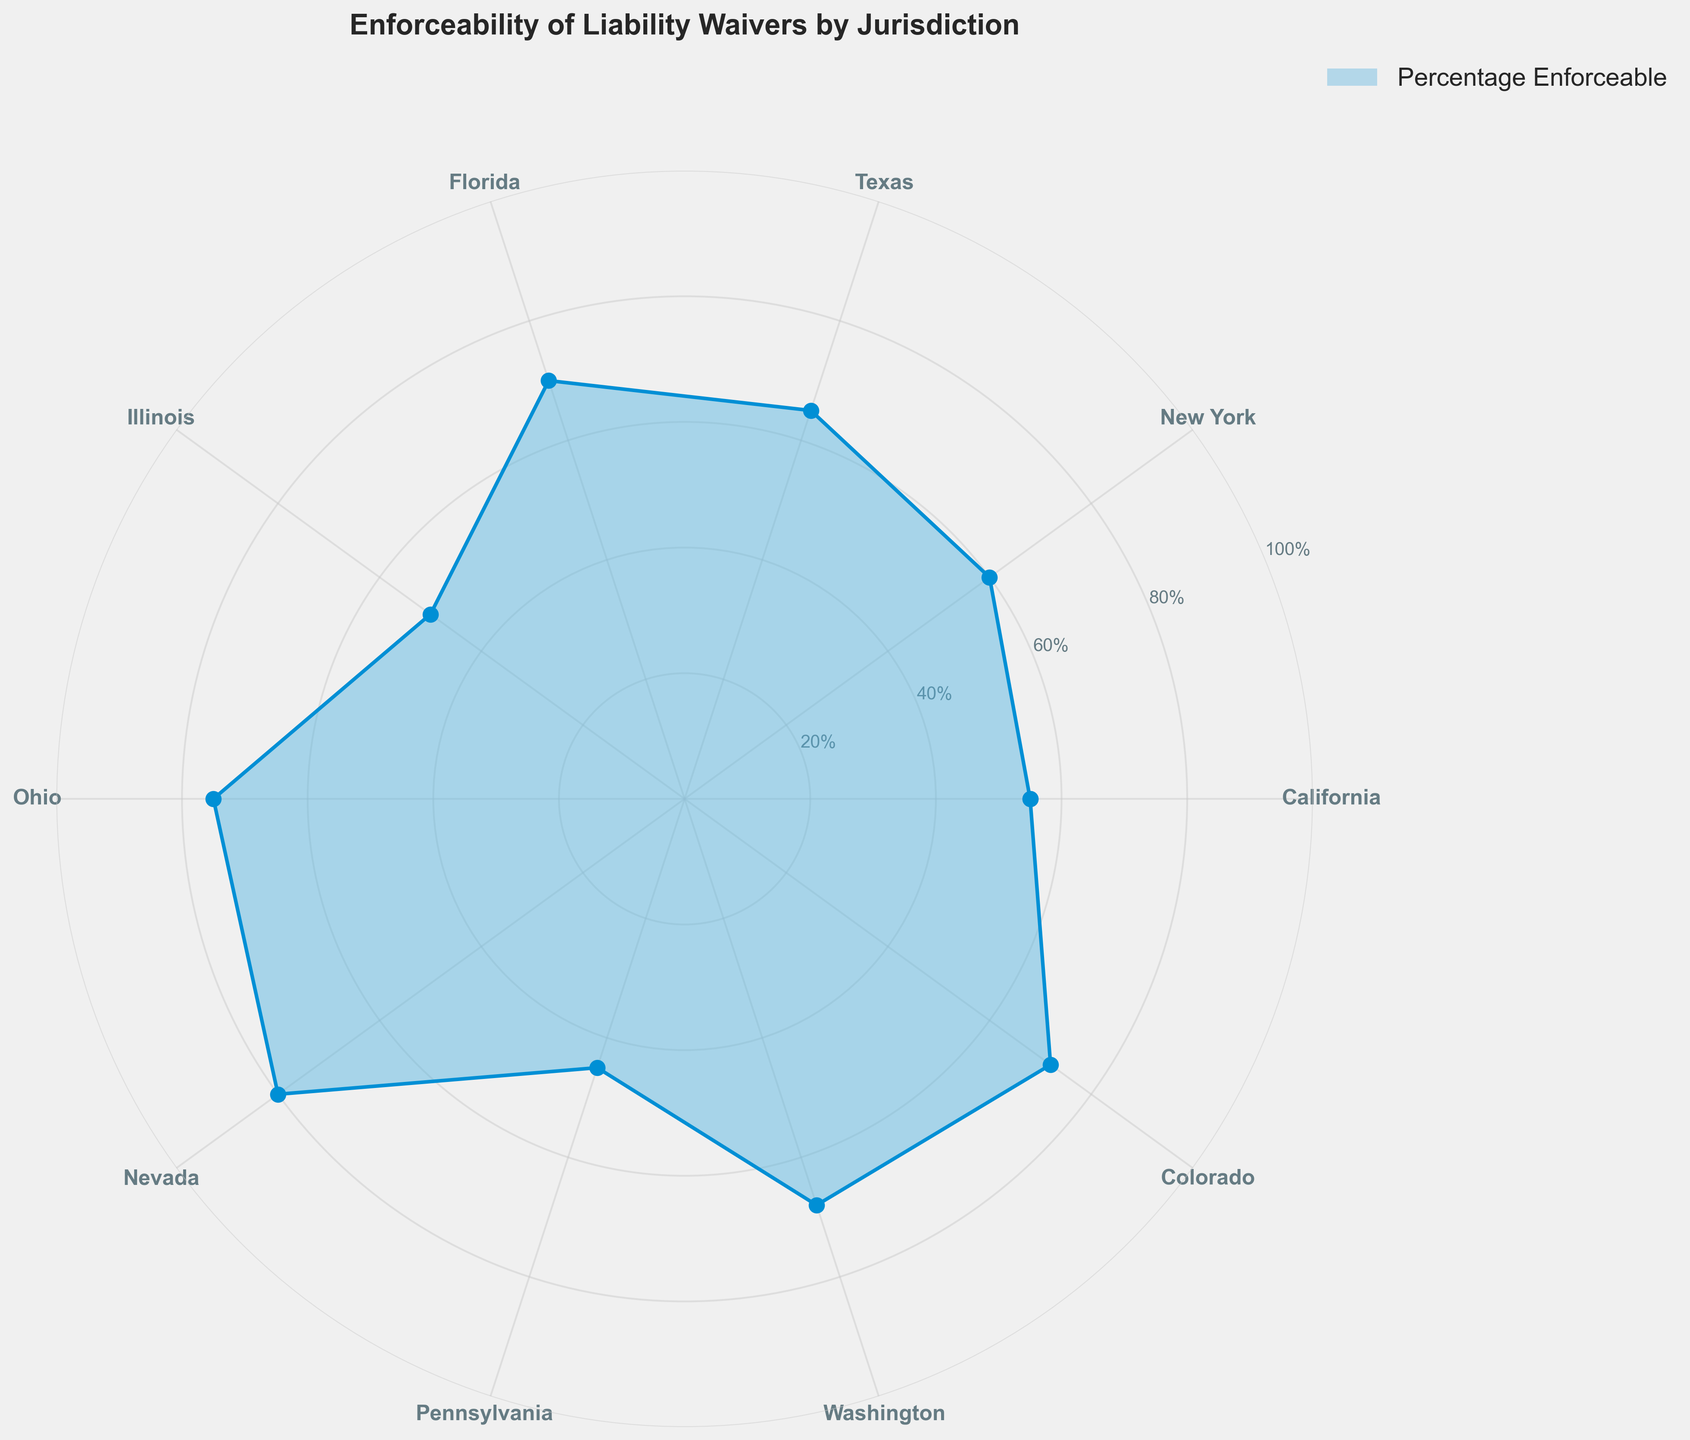what is the highest percentage of enforceable liability waivers among the jurisdictions? The figure shows the percentage enforceable for each jurisdiction on a polar area chart. By looking at the highest point on the chart, we see that Nevada has the highest percentage at 80%
Answer: 80% Which jurisdiction has the lowest enforceable rate for liability waivers? By observing the polar area chart, the shortest bar corresponds to Pennsylvania, indicating it has the lowest enforceable rate at 45%
Answer: Pennsylvania How many jurisdictions have an enforceability percentage higher than 65%? From the chart, we identify jurisdictions with percentages greater than 65%. They are Texas (65%), Florida (70%), Ohio (75%), Nevada (80%), Washington (68%), and Colorado (72%). Therefore, there are 6 jurisdictions.
Answer: 6 What is the average enforceability percentage across all jurisdictions? To find the average, sum up the enforceability percentages of all jurisdictions and divide by the number of jurisdictions: (55 + 60 + 65 + 70 + 50 + 75 + 80 + 45 + 68 + 72) / 10 = 64%
Answer: 64% Which jurisdiction has an enforceability percentage exactly in the middle range (median) of the data? To find the median, first order the percentages: 45%, 50%, 55%, 60%, 65%, 68%, 70%, 72%, 75%, 80%. The middle values are 65% and 68%, so the jurisdiction with 68% is Washington.
Answer: Washington By how much does the enforceability percentage in Texas exceed that in Pennsylvania? The enforceability percentage in Texas is 65% and in Pennsylvania is 45%. The difference is 65% - 45% = 20%.
Answer: 20% Which two jurisdictions have the closest enforceability percentages? By comparing the percentages of all jurisdictions on the chart, Illinois (50%) and Pennsylvania (45%) have the smallest difference: 50% - 45% = 5%.
Answer: Illinois and Pennsylvania What is the range of enforceability percentages across all jurisdictions? The range is the difference between the highest and lowest percentages. The highest is 80% (Nevada) and the lowest is 45% (Pennsylvania). Therefore, the range is 80% - 45% = 35%.
Answer: 35% How does the enforceability percentage of Colorado compare to the national average? The national average enforceability percentage is 64%. Colorado has an enforceability percentage of 72%. Comparing the two, 72% is higher than 64%.
Answer: Higher 